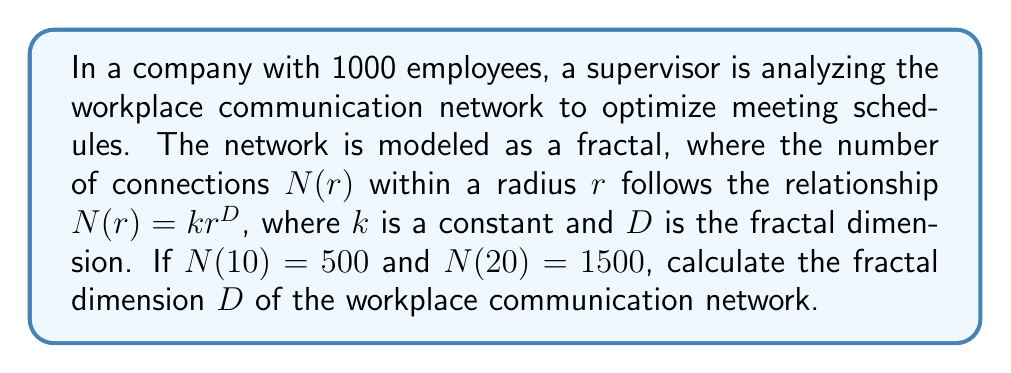What is the answer to this math problem? To solve this problem, we'll use the given relationship $N(r) = kr^D$ and the two data points provided.

Step 1: Set up equations using the given data
For $r = 10$: $500 = k(10)^D$
For $r = 20$: $1500 = k(20)^D$

Step 2: Divide the second equation by the first
$$\frac{1500}{500} = \frac{k(20)^D}{k(10)^D}$$

Step 3: Simplify
$$3 = \left(\frac{20}{10}\right)^D = 2^D$$

Step 4: Take the logarithm of both sides
$$\log_2(3) = D$$

Step 5: Solve for D
$$D = \frac{\log(3)}{\log(2)} \approx 1.5850$$

The fractal dimension $D$ represents the complexity of the communication network. A higher value indicates a more intricate network with potentially more efficient information flow, which could help the supervisor in optimizing meeting schedules and reducing unnecessary meetings.
Answer: $D \approx 1.5850$ 